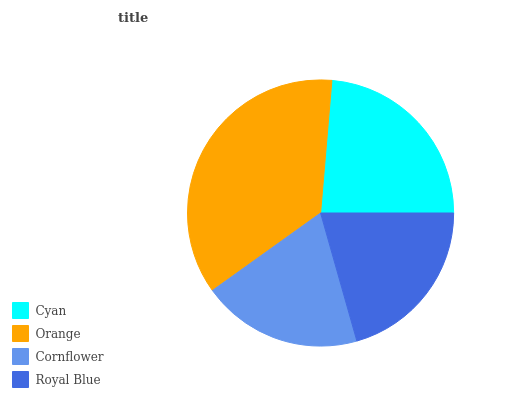Is Cornflower the minimum?
Answer yes or no. Yes. Is Orange the maximum?
Answer yes or no. Yes. Is Orange the minimum?
Answer yes or no. No. Is Cornflower the maximum?
Answer yes or no. No. Is Orange greater than Cornflower?
Answer yes or no. Yes. Is Cornflower less than Orange?
Answer yes or no. Yes. Is Cornflower greater than Orange?
Answer yes or no. No. Is Orange less than Cornflower?
Answer yes or no. No. Is Cyan the high median?
Answer yes or no. Yes. Is Royal Blue the low median?
Answer yes or no. Yes. Is Royal Blue the high median?
Answer yes or no. No. Is Cyan the low median?
Answer yes or no. No. 